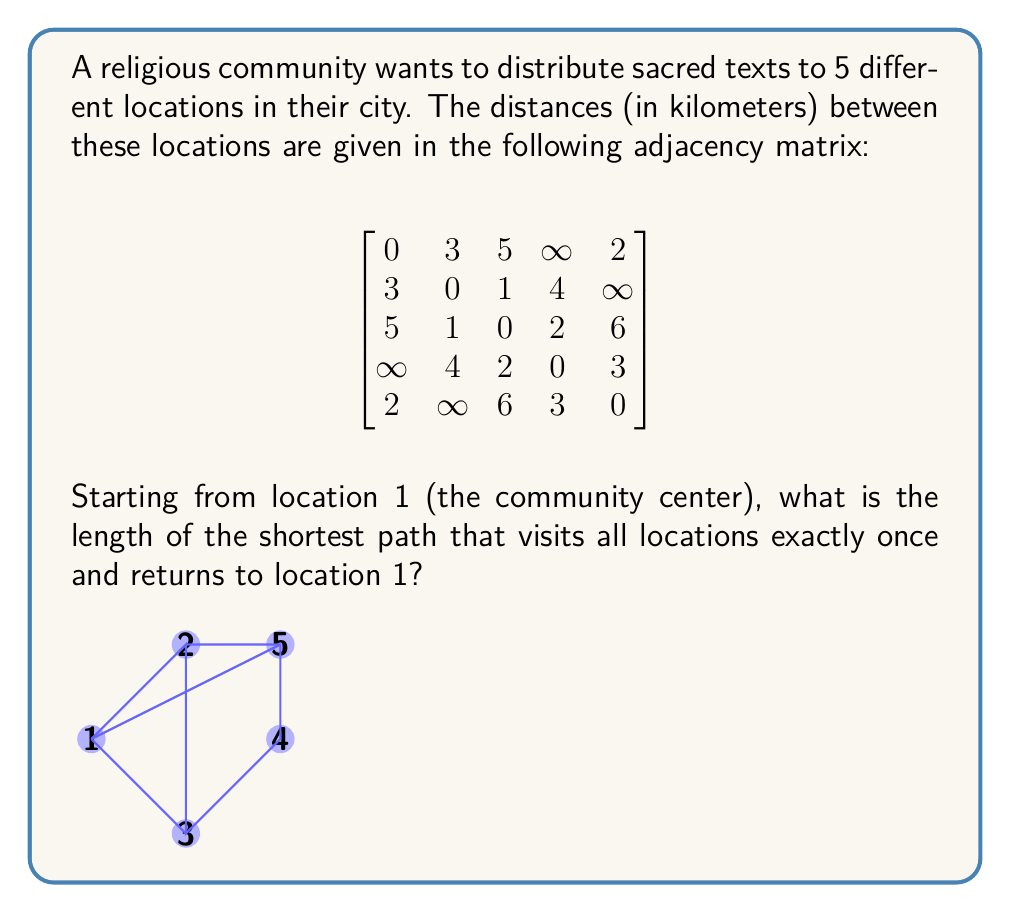Can you solve this math problem? To solve this problem, we need to find the shortest Hamiltonian cycle in the given graph. This is known as the Traveling Salesman Problem (TSP), which is NP-hard. For a small number of vertices like in this case, we can use a brute-force approach.

Steps:
1. List all possible permutations of vertices 2, 3, 4, and 5 (since we start and end at vertex 1).
2. For each permutation, calculate the total distance of the path including the return to vertex 1.
3. Choose the permutation with the minimum total distance.

Permutations and their distances:
1. 1-2-3-4-5-1: $3 + 1 + 2 + 3 + 2 = 11$
2. 1-2-3-5-4-1: $3 + 1 + 6 + 3 + \infty = \infty$
3. 1-2-4-3-5-1: $3 + 4 + 2 + 6 + 2 = 17$
4. 1-2-4-5-3-1: $3 + 4 + 3 + 6 + 5 = 21$
5. 1-2-5-3-4-1: $3 + \infty + 6 + 2 + \infty = \infty$
6. 1-2-5-4-3-1: $3 + \infty + 3 + 2 + 5 = \infty$
7. 1-3-2-4-5-1: $5 + 1 + 4 + 3 + 2 = 15$
8. 1-3-2-5-4-1: $5 + 1 + \infty + 3 + \infty = \infty$
9. 1-3-4-2-5-1: $5 + 2 + 4 + \infty + 2 = \infty$
10. 1-3-4-5-2-1: $5 + 2 + 3 + \infty + 3 = \infty$
11. 1-3-5-2-4-1: $5 + 6 + \infty + 4 + \infty = \infty$
12. 1-3-5-4-2-1: $5 + 6 + 3 + 4 + 3 = 21$
13. 1-4-2-3-5-1: $\infty + 4 + 1 + 6 + 2 = \infty$
14. 1-4-2-5-3-1: $\infty + 4 + \infty + 6 + 5 = \infty$
15. 1-4-3-2-5-1: $\infty + 2 + 1 + \infty + 2 = \infty$
16. 1-4-3-5-2-1: $\infty + 2 + 6 + \infty + 3 = \infty$
17. 1-4-5-2-3-1: $\infty + 3 + \infty + 1 + 5 = \infty$
18. 1-4-5-3-2-1: $\infty + 3 + 6 + 1 + 3 = \infty$
19. 1-5-2-3-4-1: $2 + \infty + 1 + 2 + \infty = \infty$
20. 1-5-2-4-3-1: $2 + \infty + 4 + 2 + 5 = \infty$
21. 1-5-3-2-4-1: $2 + 6 + 1 + 4 + \infty = \infty$
22. 1-5-3-4-2-1: $2 + 6 + 2 + 4 + 3 = 17$
23. 1-5-4-2-3-1: $2 + 3 + 4 + 1 + 5 = 15$
24. 1-5-4-3-2-1: $2 + 3 + 2 + 1 + 3 = 11$

The shortest path has a length of 11 km.
Answer: The length of the shortest path visiting all locations once and returning to the starting point is 11 km. This can be achieved by following the path 1-2-3-4-5-1 or 1-5-4-3-2-1. 